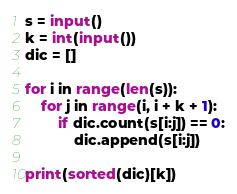<code> <loc_0><loc_0><loc_500><loc_500><_Python_>s = input()
k = int(input())
dic = []

for i in range(len(s)):
    for j in range(i, i + k + 1):
        if dic.count(s[i:j]) == 0:
            dic.append(s[i:j])

print(sorted(dic)[k])</code> 